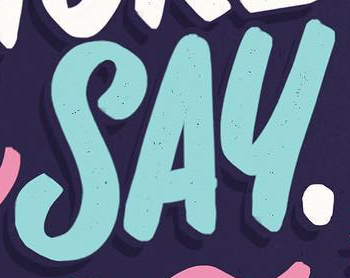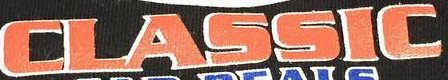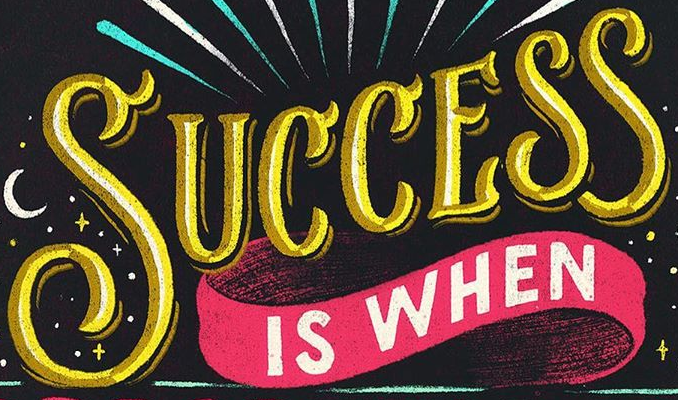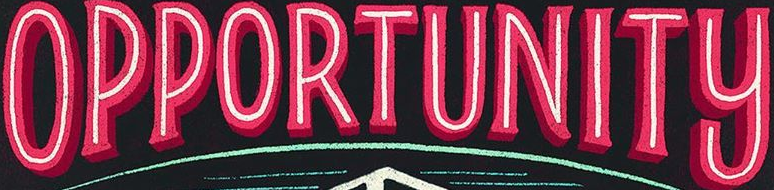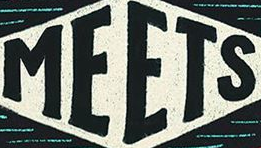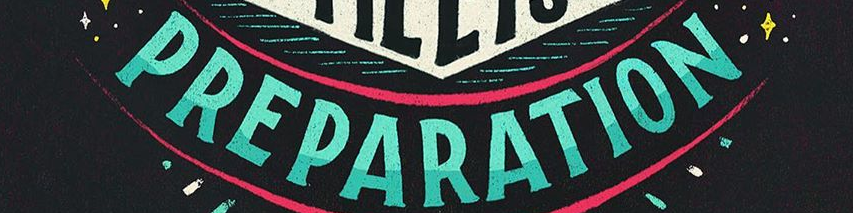What text appears in these images from left to right, separated by a semicolon? SAY; CLASSIC; SUCCESS; OPPORTUNITY; MEETS; PREPARATION 